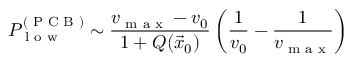Convert formula to latex. <formula><loc_0><loc_0><loc_500><loc_500>P _ { l o w } ^ { ( P C B ) } \sim \frac { v _ { \max } - v _ { 0 } } { 1 + Q ( \vec { x } _ { 0 } ) } \left ( \frac { 1 } { v _ { 0 } } - \frac { 1 } { v _ { \max } } \right )</formula> 